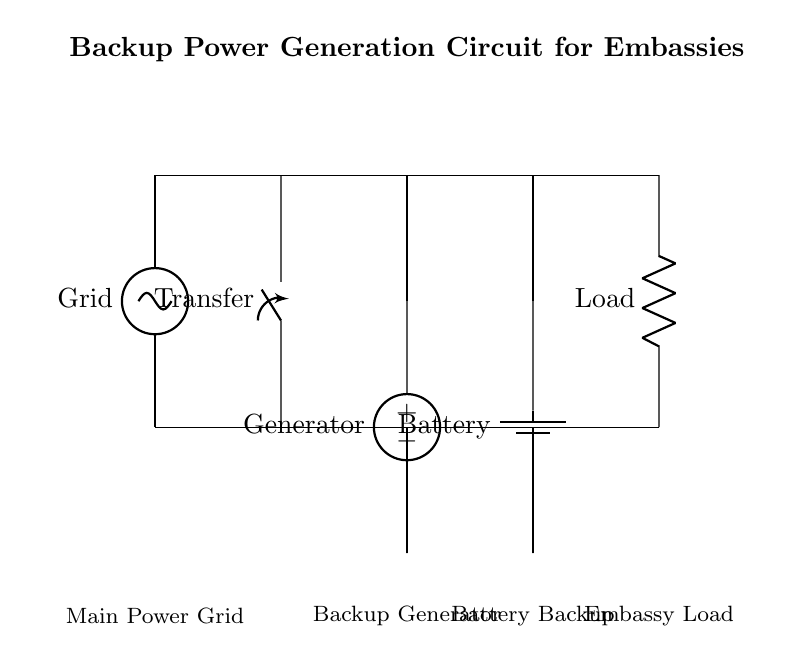What components are present in this circuit? The components in the circuit include a grid supply, a transfer switch, a generator, a battery, and a load. Each component serves a specific function in providing backup power to the embassy.
Answer: Grid, Transfer switch, Generator, Battery, Load What is the purpose of the transfer switch in this circuit? The transfer switch is designed to switch the supply between the main power grid and the backup sources (generator and battery) to ensure continuous power supply during outages.
Answer: To switch power sources How many backup power sources are included in the circuit? The circuit includes two backup power sources: a generator and a battery. Both are connected to provide alternative power in case the main grid fails.
Answer: Two What does the load represent in this circuit? The load represents the actual devices or systems in the embassy that require power to operate. This could include lighting, computers, and security systems.
Answer: Embassy devices In case of a power outage, which component will provide immediate backup power? The generator will provide immediate backup power since it is specifically designed to activate quickly when the grid fails, ensuring minimal disruption.
Answer: Generator How does the battery contribute to the circuit during a prolonged power outage? The battery serves as a secondary backup that can supply power to the load when the generator may not be operational, ensuring the embassy's power needs are met for longer periods.
Answer: Provides longer backup supply What voltage does the generator output in this circuit? The esquema does not specify an exact voltage for the generator, but it typically provides a standard voltage output, often around 120V or 240V depending on the region and appliance requirements.
Answer: Standard voltage (typically 120V or 240V) 